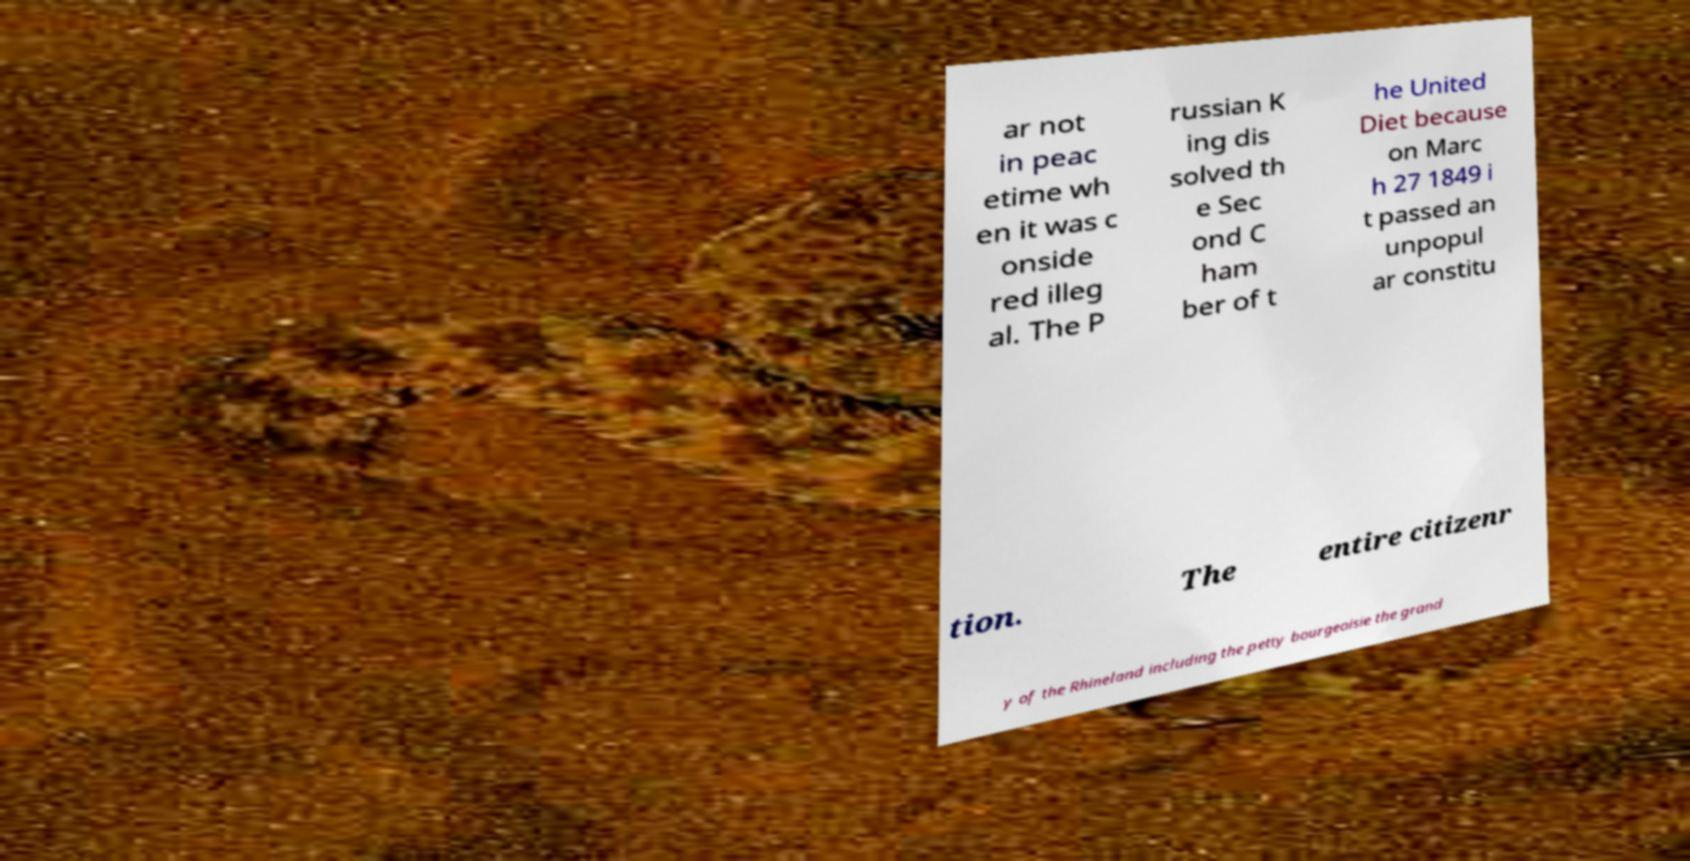What messages or text are displayed in this image? I need them in a readable, typed format. ar not in peac etime wh en it was c onside red illeg al. The P russian K ing dis solved th e Sec ond C ham ber of t he United Diet because on Marc h 27 1849 i t passed an unpopul ar constitu tion. The entire citizenr y of the Rhineland including the petty bourgeoisie the grand 